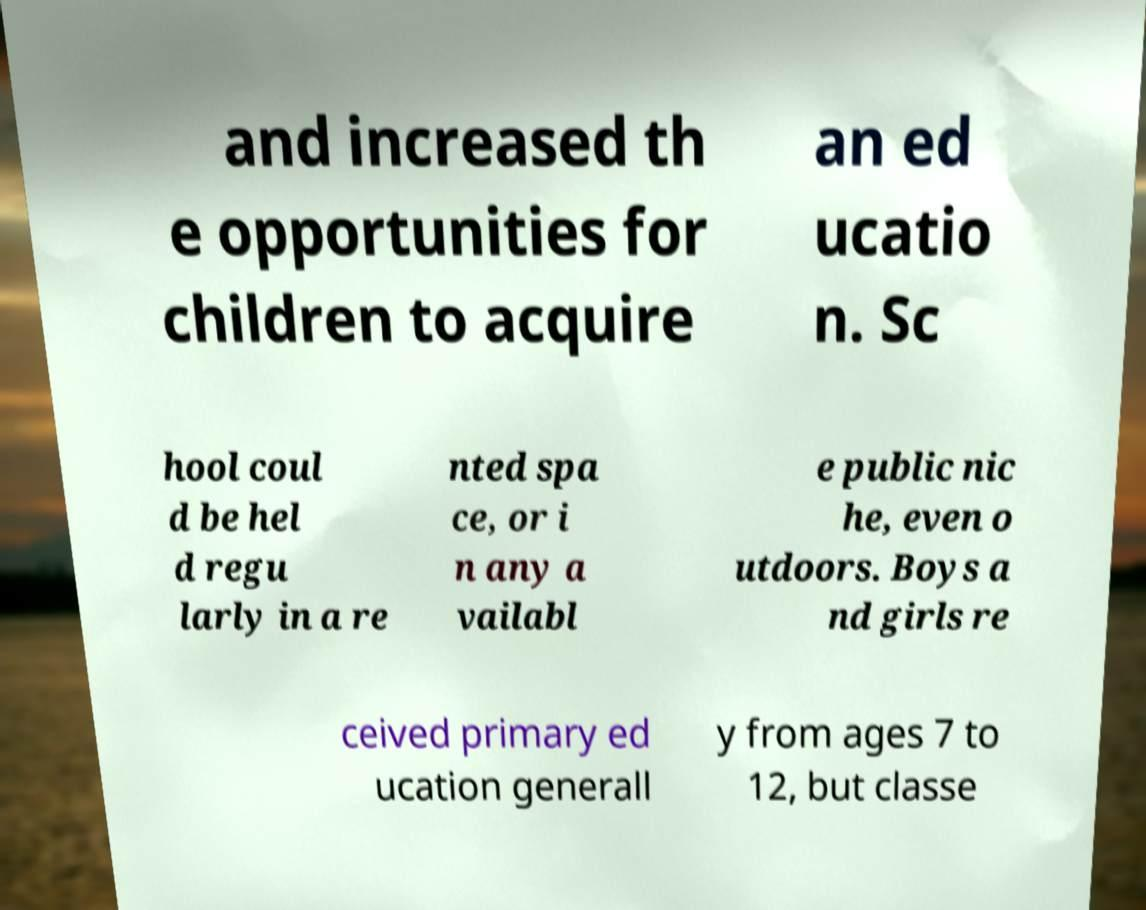There's text embedded in this image that I need extracted. Can you transcribe it verbatim? and increased th e opportunities for children to acquire an ed ucatio n. Sc hool coul d be hel d regu larly in a re nted spa ce, or i n any a vailabl e public nic he, even o utdoors. Boys a nd girls re ceived primary ed ucation generall y from ages 7 to 12, but classe 